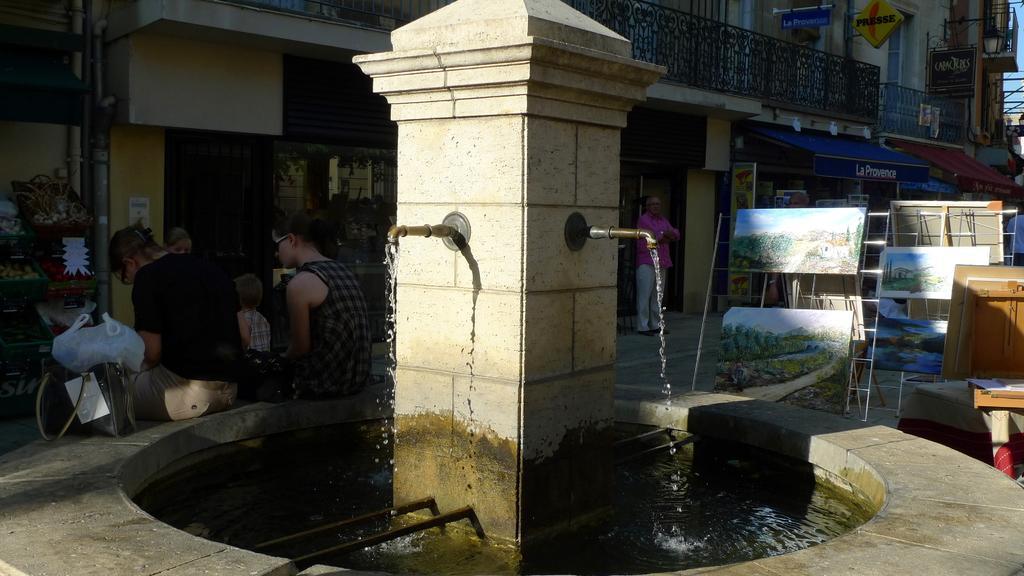Can you describe this image briefly? As we can see in the image there are buildings, fence, pipe, water, group of people and ladder. The image is little dark. 